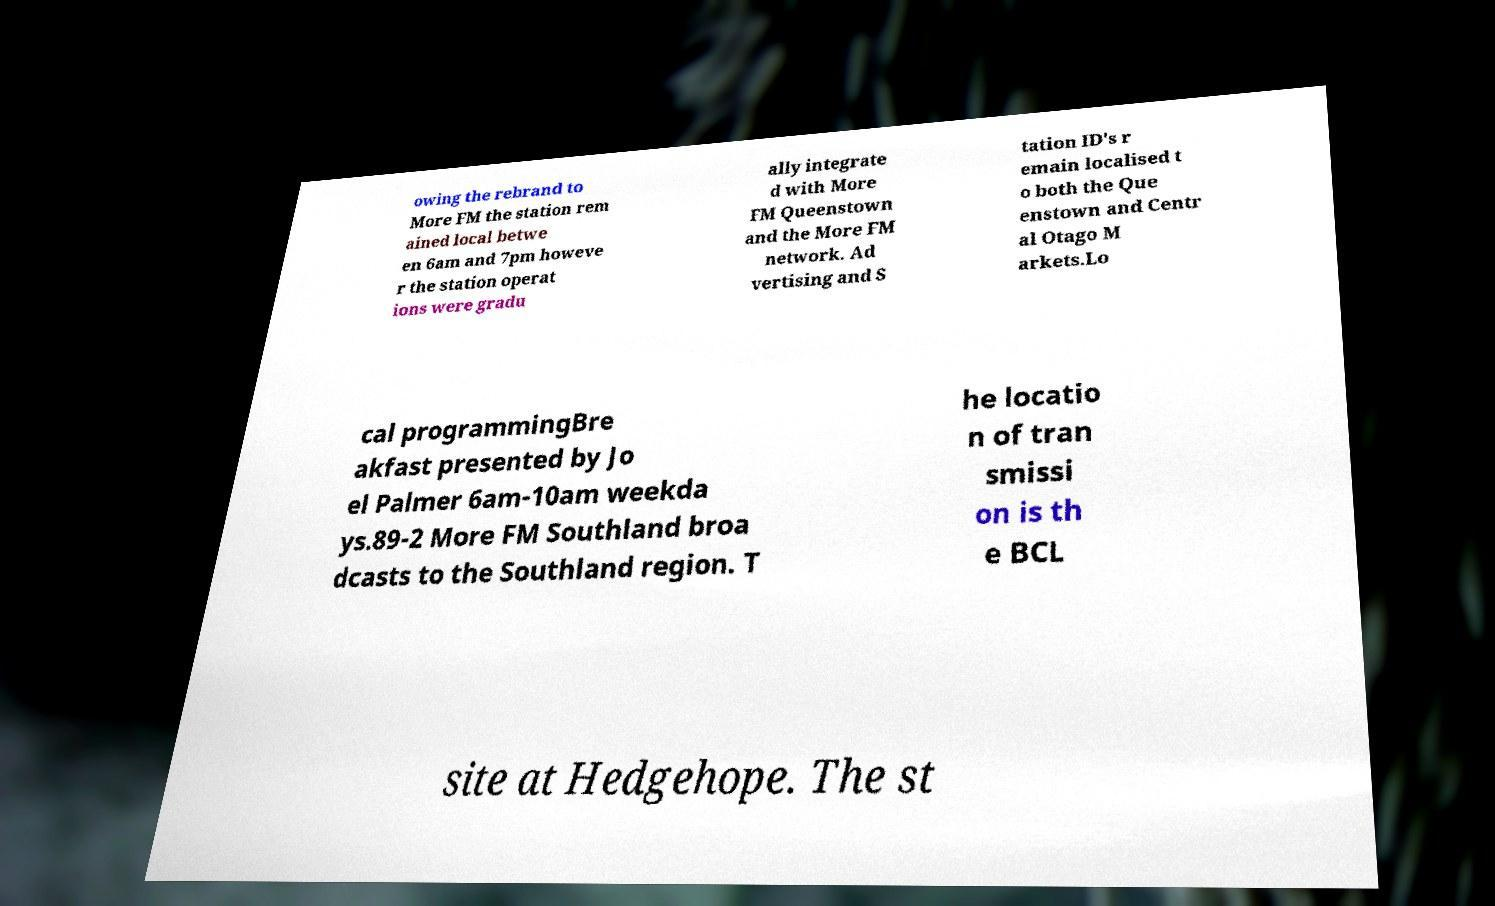Please identify and transcribe the text found in this image. owing the rebrand to More FM the station rem ained local betwe en 6am and 7pm howeve r the station operat ions were gradu ally integrate d with More FM Queenstown and the More FM network. Ad vertising and S tation ID's r emain localised t o both the Que enstown and Centr al Otago M arkets.Lo cal programmingBre akfast presented by Jo el Palmer 6am-10am weekda ys.89-2 More FM Southland broa dcasts to the Southland region. T he locatio n of tran smissi on is th e BCL site at Hedgehope. The st 